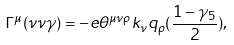Convert formula to latex. <formula><loc_0><loc_0><loc_500><loc_500>\Gamma ^ { \mu } ( \nu \nu \gamma ) = - e \theta ^ { \mu \nu \rho } k _ { \nu } q _ { \rho } ( \frac { 1 - \gamma _ { 5 } } { 2 } ) ,</formula> 